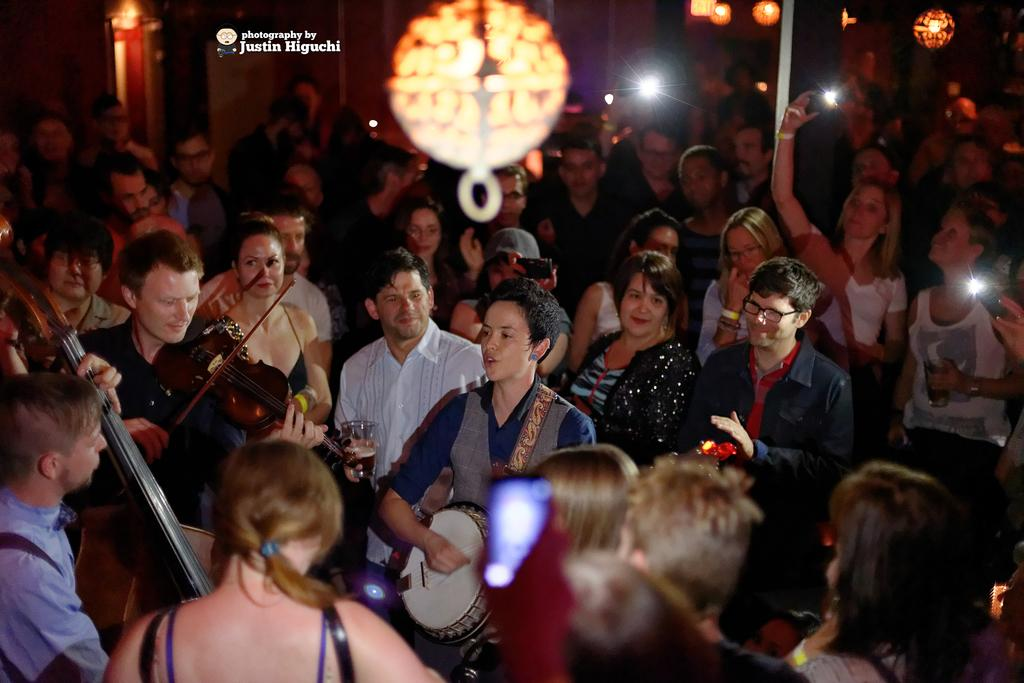How many people are in the image? There is a group of people in the image, but the exact number cannot be determined from the provided facts. What are the people in the image doing? The presence of musical instruments suggests that the people might be playing music. What else can be seen in the image besides the people? Mobiles, glasses, lights, walls, and some text are visible in the image. Can you describe the background of the image? The background of the image includes lights, walls, and some text. What type of cream can be seen on the teeth of the people in the image? There is no mention of cream or teeth in the provided facts, so it cannot be determined if they are present in the image. 